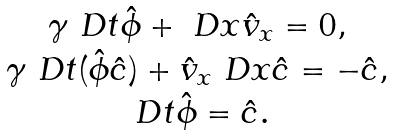<formula> <loc_0><loc_0><loc_500><loc_500>\begin{array} { c } \gamma \ D t { \hat { \phi } } + \ D x { \hat { v } _ { x } } = 0 , \\ \gamma \ D t ( { \hat { \phi } } { \hat { c } } ) + { \hat { v } _ { x } } \ D x { \hat { c } } = - { \hat { c } } , \\ \ D t { \hat { \phi } } = { \hat { c } } . \end{array}</formula> 